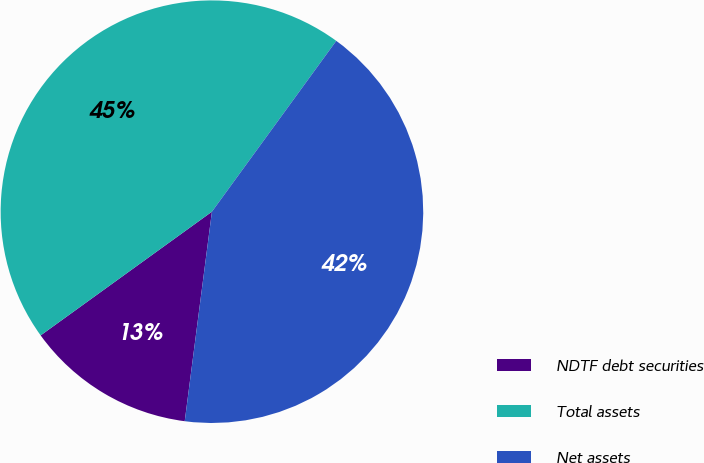<chart> <loc_0><loc_0><loc_500><loc_500><pie_chart><fcel>NDTF debt securities<fcel>Total assets<fcel>Net assets<nl><fcel>12.99%<fcel>44.97%<fcel>42.04%<nl></chart> 